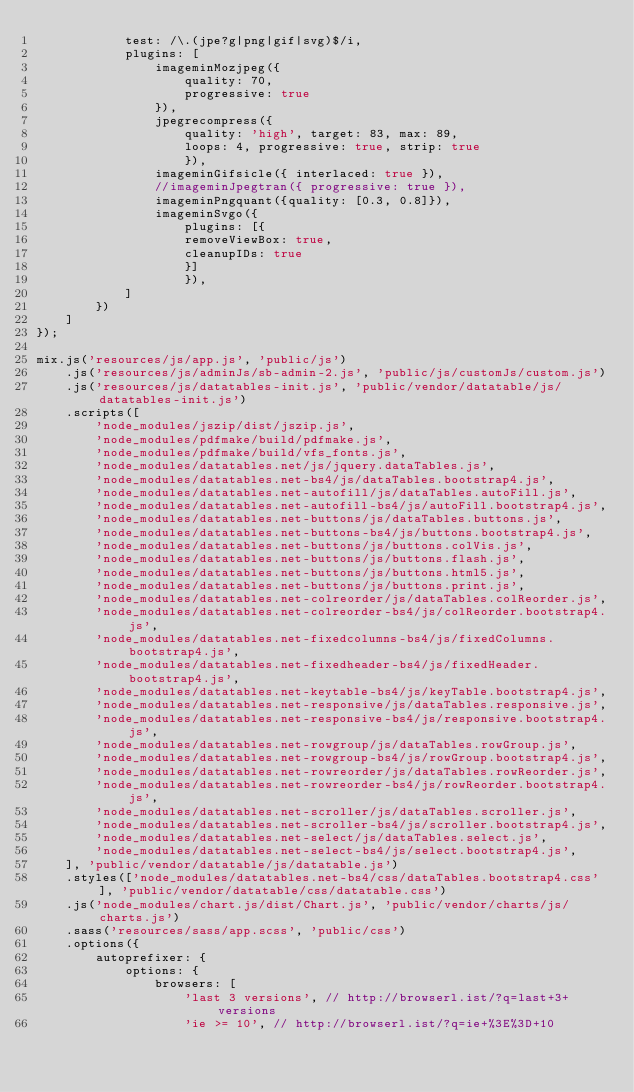<code> <loc_0><loc_0><loc_500><loc_500><_JavaScript_>            test: /\.(jpe?g|png|gif|svg)$/i,
            plugins: [
                imageminMozjpeg({
                    quality: 70,
                    progressive: true
                }),
                jpegrecompress({
                    quality: 'high', target: 83, max: 89,
                    loops: 4, progressive: true, strip: true
                    }),
                imageminGifsicle({ interlaced: true }),
                //imageminJpegtran({ progressive: true }),
                imageminPngquant({quality: [0.3, 0.8]}),
                imageminSvgo({
                    plugins: [{
                    removeViewBox: true,
                    cleanupIDs: true
                    }]
                    }),
            ]
        })
    ]
});

mix.js('resources/js/app.js', 'public/js')
    .js('resources/js/adminJs/sb-admin-2.js', 'public/js/customJs/custom.js')
    .js('resources/js/datatables-init.js', 'public/vendor/datatable/js/datatables-init.js')
    .scripts([
        'node_modules/jszip/dist/jszip.js',
        'node_modules/pdfmake/build/pdfmake.js',
        'node_modules/pdfmake/build/vfs_fonts.js',
        'node_modules/datatables.net/js/jquery.dataTables.js',
        'node_modules/datatables.net-bs4/js/dataTables.bootstrap4.js',
        'node_modules/datatables.net-autofill/js/dataTables.autoFill.js',
        'node_modules/datatables.net-autofill-bs4/js/autoFill.bootstrap4.js',
        'node_modules/datatables.net-buttons/js/dataTables.buttons.js',
        'node_modules/datatables.net-buttons-bs4/js/buttons.bootstrap4.js',
        'node_modules/datatables.net-buttons/js/buttons.colVis.js',
        'node_modules/datatables.net-buttons/js/buttons.flash.js',
        'node_modules/datatables.net-buttons/js/buttons.html5.js',
        'node_modules/datatables.net-buttons/js/buttons.print.js',
        'node_modules/datatables.net-colreorder/js/dataTables.colReorder.js',
        'node_modules/datatables.net-colreorder-bs4/js/colReorder.bootstrap4.js',
        'node_modules/datatables.net-fixedcolumns-bs4/js/fixedColumns.bootstrap4.js',
        'node_modules/datatables.net-fixedheader-bs4/js/fixedHeader.bootstrap4.js',
        'node_modules/datatables.net-keytable-bs4/js/keyTable.bootstrap4.js',
        'node_modules/datatables.net-responsive/js/dataTables.responsive.js',
        'node_modules/datatables.net-responsive-bs4/js/responsive.bootstrap4.js',
        'node_modules/datatables.net-rowgroup/js/dataTables.rowGroup.js',
        'node_modules/datatables.net-rowgroup-bs4/js/rowGroup.bootstrap4.js',
        'node_modules/datatables.net-rowreorder/js/dataTables.rowReorder.js',
        'node_modules/datatables.net-rowreorder-bs4/js/rowReorder.bootstrap4.js',
        'node_modules/datatables.net-scroller/js/dataTables.scroller.js',
        'node_modules/datatables.net-scroller-bs4/js/scroller.bootstrap4.js',
        'node_modules/datatables.net-select/js/dataTables.select.js',
        'node_modules/datatables.net-select-bs4/js/select.bootstrap4.js',
    ], 'public/vendor/datatable/js/datatable.js')
    .styles(['node_modules/datatables.net-bs4/css/dataTables.bootstrap4.css'], 'public/vendor/datatable/css/datatable.css')
    .js('node_modules/chart.js/dist/Chart.js', 'public/vendor/charts/js/charts.js')
    .sass('resources/sass/app.scss', 'public/css')
    .options({
        autoprefixer: {
            options: {
                browsers: [
                    'last 3 versions', // http://browserl.ist/?q=last+3+versions
                    'ie >= 10', // http://browserl.ist/?q=ie+%3E%3D+10</code> 